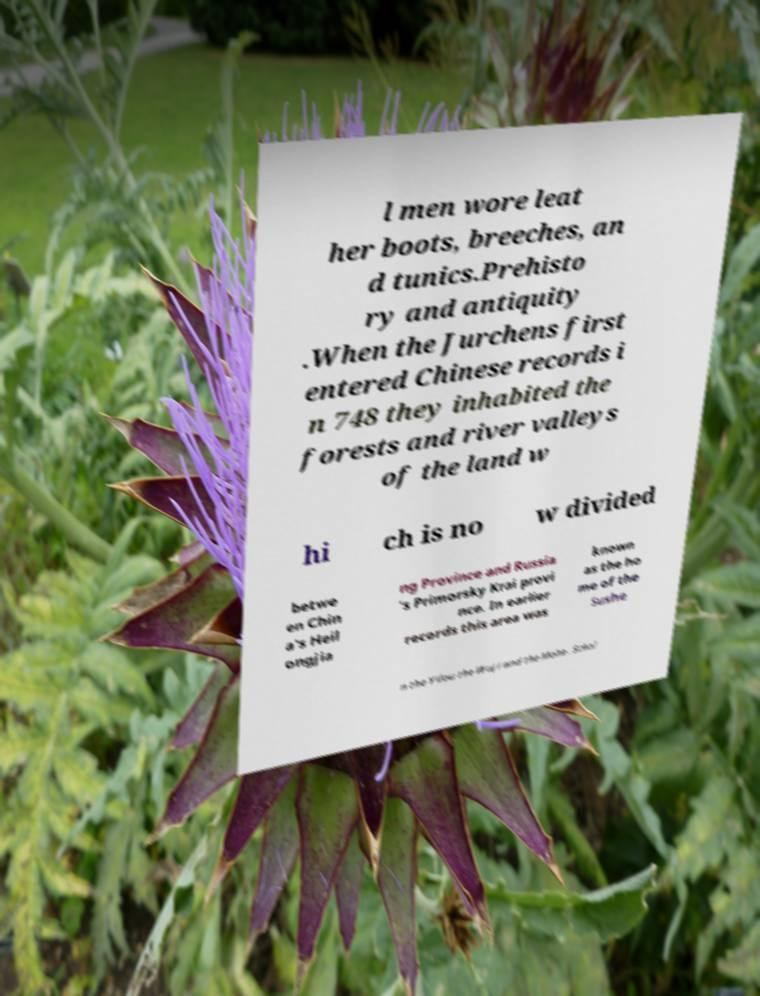For documentation purposes, I need the text within this image transcribed. Could you provide that? l men wore leat her boots, breeches, an d tunics.Prehisto ry and antiquity .When the Jurchens first entered Chinese records i n 748 they inhabited the forests and river valleys of the land w hi ch is no w divided betwe en Chin a's Heil ongjia ng Province and Russia 's Primorsky Krai provi nce. In earlier records this area was known as the ho me of the Sushe n the Yilou the Wuji and the Mohe . Schol 